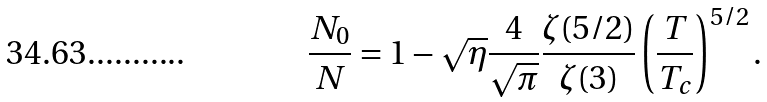<formula> <loc_0><loc_0><loc_500><loc_500>\frac { N _ { 0 } } { N } = 1 - \sqrt { \eta } \frac { 4 } { \sqrt { \pi } } \frac { \zeta ( 5 / 2 ) } { \zeta ( 3 ) } \left ( \frac { T } { T _ { c } } \right ) ^ { 5 / 2 } .</formula> 